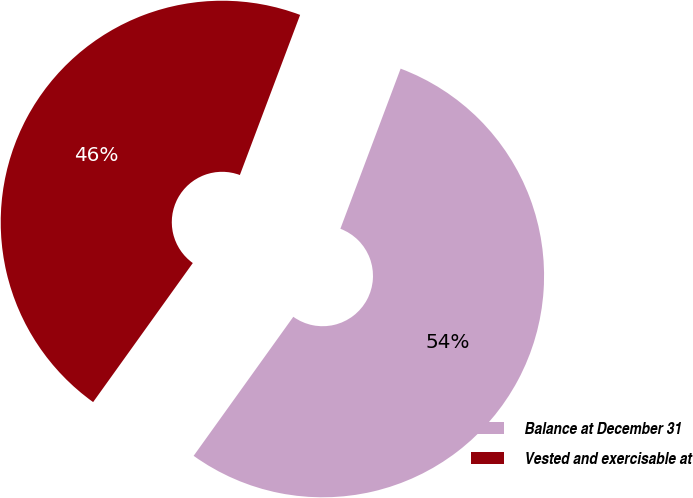Convert chart to OTSL. <chart><loc_0><loc_0><loc_500><loc_500><pie_chart><fcel>Balance at December 31<fcel>Vested and exercisable at<nl><fcel>54.17%<fcel>45.83%<nl></chart> 